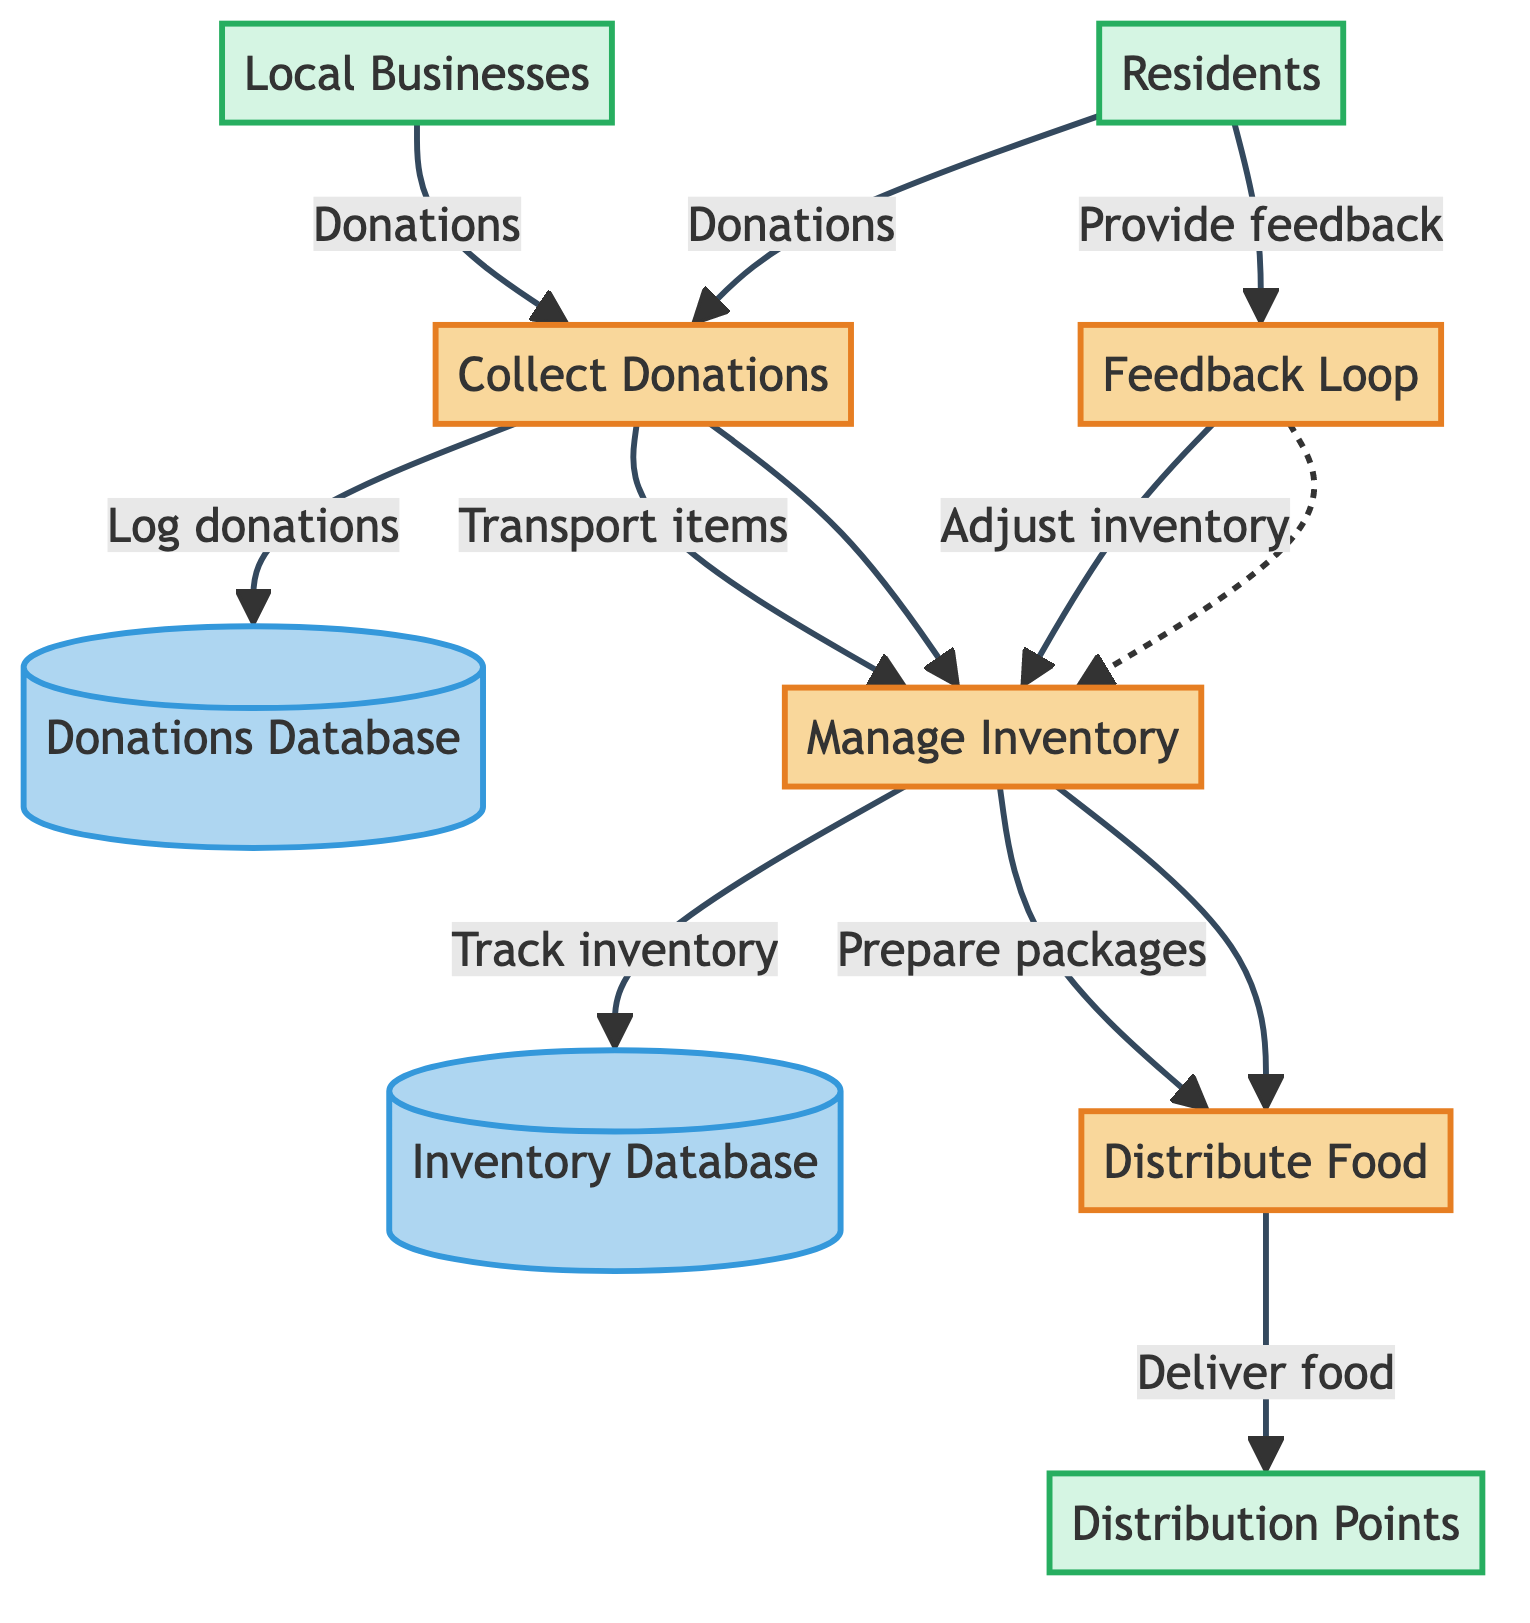What are the four main processes in the diagram? The diagram lists four main processes: "Collect Donations", "Manage Inventory", "Distribute Food", and "Feedback Loop". These processes represent the key functions within the local charity food distribution system.
Answer: Collect Donations, Manage Inventory, Distribute Food, Feedback Loop How many data stores are present in the diagram? There are two data stores identified in the diagram: "Donations Database" and "Inventory Database". Each data store plays a crucial role in managing information pertaining to donations and inventory levels.
Answer: 2 Which external entity provides monetary donations? The external entity that contributes to monetary donations is the "Residents". They are recognized as community members who support the food distribution system through donations, both food and monetary.
Answer: Residents What is the purpose of the Feedback Loop process? The Feedback Loop process is designed to collect feedback from residents about the quality and helpfulness of food distributions. This information is then utilized to enhance future distributions based on recipient experiences.
Answer: Collect feedback Which data flow comes directly from the "Collect Donations" process to the "Donations Database"? The data flow that connects "Collect Donations" to "Donations Database" is described as "Logs information about the gathered donations". This flow ensures that all donations are recorded systematically for tracking purposes.
Answer: Logs information about the gathered donations What actions are taken after the food items are transported to the "Manage Inventory" process? After food items are transported to the "Manage Inventory" process, the actions taken include tracking inventory levels, which is logged into the "Inventory Database", and preparing food packages for distribution to the community.
Answer: Track inventory, prepare packages How does the "Feedback Loop" impact the "Manage Inventory" process? The "Feedback Loop" influences the "Manage Inventory" process by providing feedback from residents, which is then used to adjust inventory management and improve future distributions. This feedback creates a cycle of continuous improvement for inventory practices.
Answer: Adjust inventory管理 What type of entities contribute to the "Collect Donations" process? The entities that contribute to the "Collect Donations" process are "Local Businesses" and "Residents". Both types of entities are integral to gathering donations necessary for food distribution efforts.
Answer: Local Businesses, Residents Which process directly leads to the delivery of food packages? The process that directly results in the delivery of food packages is "Distribute Food". This process encompasses the logistics and actions required to deliver prepared food packages to distribution points where they can reach residents.
Answer: Distribute Food 